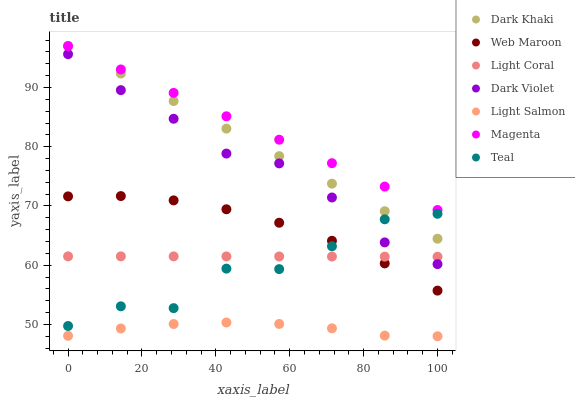Does Light Salmon have the minimum area under the curve?
Answer yes or no. Yes. Does Magenta have the maximum area under the curve?
Answer yes or no. Yes. Does Web Maroon have the minimum area under the curve?
Answer yes or no. No. Does Web Maroon have the maximum area under the curve?
Answer yes or no. No. Is Magenta the smoothest?
Answer yes or no. Yes. Is Teal the roughest?
Answer yes or no. Yes. Is Light Salmon the smoothest?
Answer yes or no. No. Is Light Salmon the roughest?
Answer yes or no. No. Does Light Salmon have the lowest value?
Answer yes or no. Yes. Does Web Maroon have the lowest value?
Answer yes or no. No. Does Magenta have the highest value?
Answer yes or no. Yes. Does Web Maroon have the highest value?
Answer yes or no. No. Is Dark Violet less than Dark Khaki?
Answer yes or no. Yes. Is Dark Violet greater than Light Salmon?
Answer yes or no. Yes. Does Light Coral intersect Dark Violet?
Answer yes or no. Yes. Is Light Coral less than Dark Violet?
Answer yes or no. No. Is Light Coral greater than Dark Violet?
Answer yes or no. No. Does Dark Violet intersect Dark Khaki?
Answer yes or no. No. 